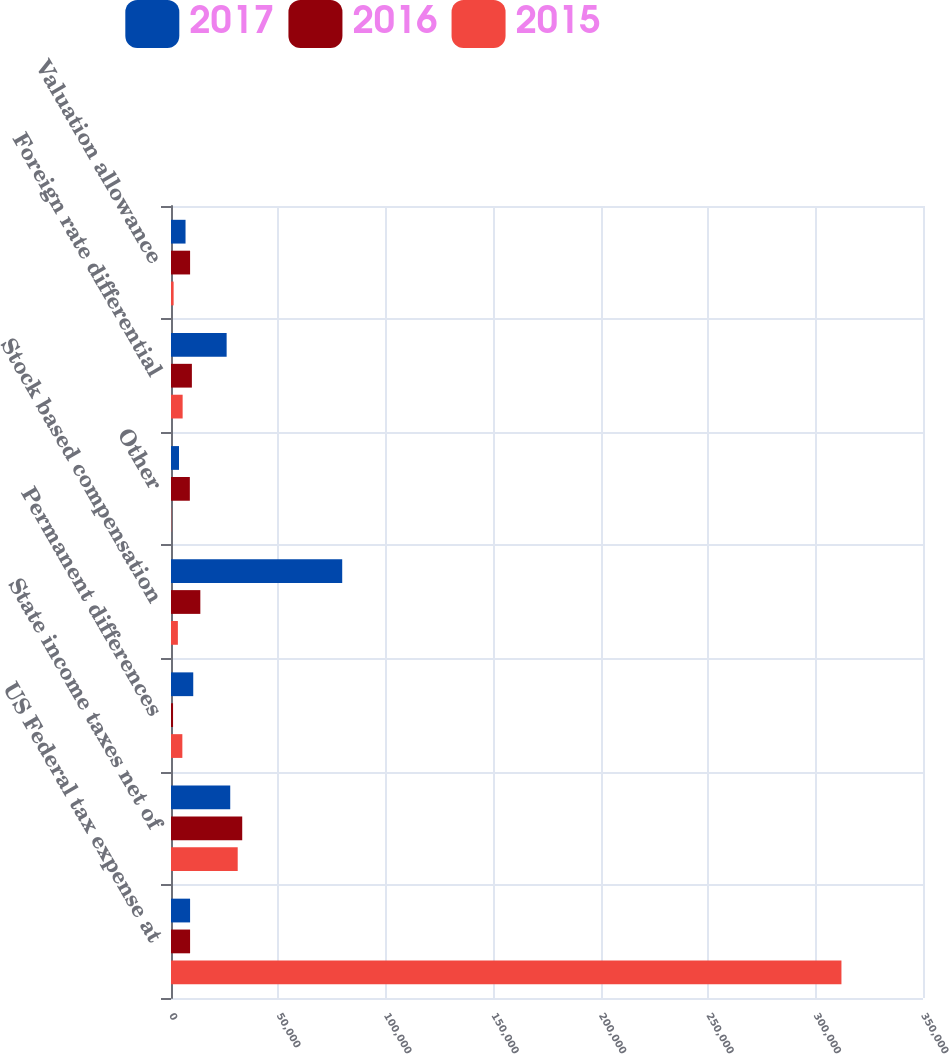<chart> <loc_0><loc_0><loc_500><loc_500><stacked_bar_chart><ecel><fcel>US Federal tax expense at<fcel>State income taxes net of<fcel>Permanent differences<fcel>Stock based compensation<fcel>Other<fcel>Foreign rate differential<fcel>Valuation allowance<nl><fcel>2017<fcel>8885<fcel>27569<fcel>10356<fcel>79687<fcel>3736<fcel>25895<fcel>6764<nl><fcel>2016<fcel>8885<fcel>33148<fcel>954<fcel>13654<fcel>8765<fcel>9720<fcel>8885<nl><fcel>2015<fcel>312042<fcel>31046<fcel>5285<fcel>3203<fcel>127<fcel>5414<fcel>1220<nl></chart> 